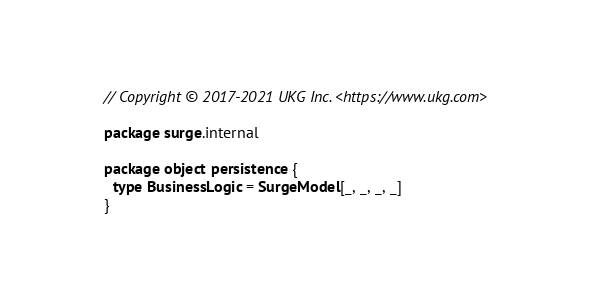<code> <loc_0><loc_0><loc_500><loc_500><_Scala_>// Copyright © 2017-2021 UKG Inc. <https://www.ukg.com>

package surge.internal

package object persistence {
  type BusinessLogic = SurgeModel[_, _, _, _]
}
</code> 